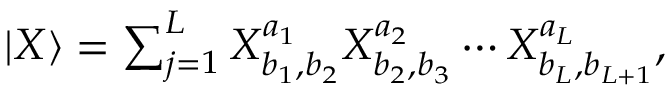<formula> <loc_0><loc_0><loc_500><loc_500>\begin{array} { r } { { | { X } \rangle } = \sum _ { j = 1 } ^ { L } X _ { b _ { 1 } , b _ { 2 } } ^ { a _ { 1 } } X _ { b _ { 2 } , b _ { 3 } } ^ { a _ { 2 } } \cdots X _ { b _ { L } , b _ { L + 1 } } ^ { a _ { L } } , } \end{array}</formula> 